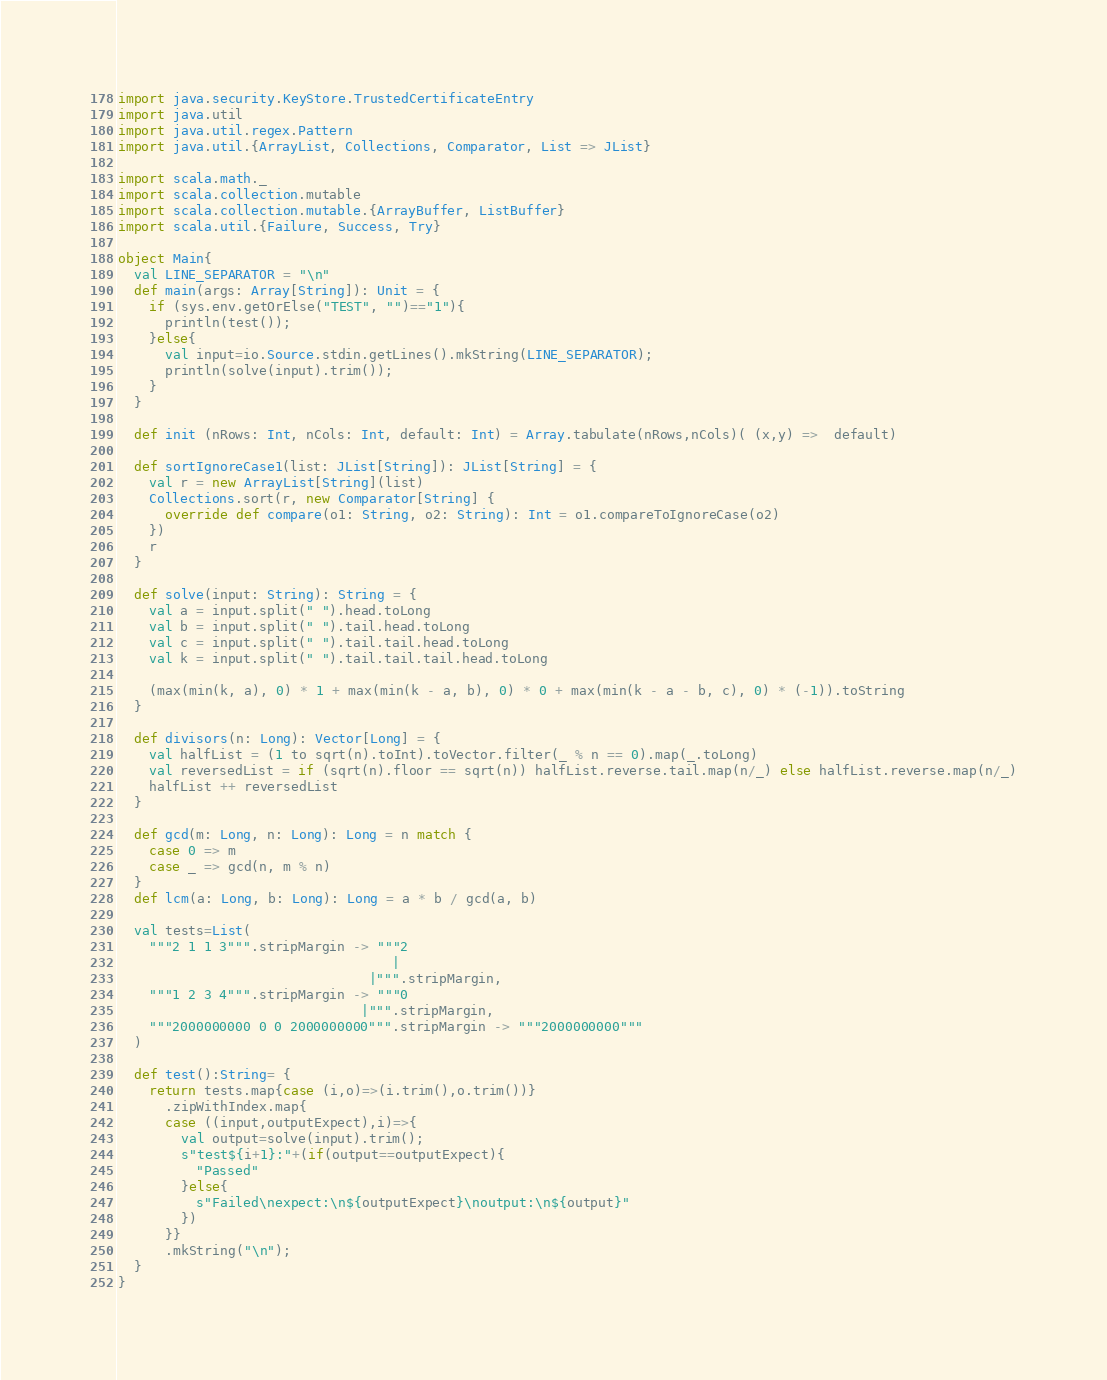<code> <loc_0><loc_0><loc_500><loc_500><_Scala_>import java.security.KeyStore.TrustedCertificateEntry
import java.util
import java.util.regex.Pattern
import java.util.{ArrayList, Collections, Comparator, List => JList}

import scala.math._
import scala.collection.mutable
import scala.collection.mutable.{ArrayBuffer, ListBuffer}
import scala.util.{Failure, Success, Try}

object Main{
  val LINE_SEPARATOR = "\n"
  def main(args: Array[String]): Unit = {
    if (sys.env.getOrElse("TEST", "")=="1"){
      println(test());
    }else{
      val input=io.Source.stdin.getLines().mkString(LINE_SEPARATOR);
      println(solve(input).trim());
    }
  }

  def init (nRows: Int, nCols: Int, default: Int) = Array.tabulate(nRows,nCols)( (x,y) =>  default)

  def sortIgnoreCase1(list: JList[String]): JList[String] = {
    val r = new ArrayList[String](list)
    Collections.sort(r, new Comparator[String] {
      override def compare(o1: String, o2: String): Int = o1.compareToIgnoreCase(o2)
    })
    r
  }

  def solve(input: String): String = {
    val a = input.split(" ").head.toLong
    val b = input.split(" ").tail.head.toLong
    val c = input.split(" ").tail.tail.head.toLong
    val k = input.split(" ").tail.tail.tail.head.toLong

    (max(min(k, a), 0) * 1 + max(min(k - a, b), 0) * 0 + max(min(k - a - b, c), 0) * (-1)).toString
  }

  def divisors(n: Long): Vector[Long] = {
    val halfList = (1 to sqrt(n).toInt).toVector.filter(_ % n == 0).map(_.toLong)
    val reversedList = if (sqrt(n).floor == sqrt(n)) halfList.reverse.tail.map(n/_) else halfList.reverse.map(n/_)
    halfList ++ reversedList
  }

  def gcd(m: Long, n: Long): Long = n match {
    case 0 => m
    case _ => gcd(n, m % n)
  }
  def lcm(a: Long, b: Long): Long = a * b / gcd(a, b)

  val tests=List(
    """2 1 1 3""".stripMargin -> """2
                                   |
                                |""".stripMargin,
    """1 2 3 4""".stripMargin -> """0
                               |""".stripMargin,
    """2000000000 0 0 2000000000""".stripMargin -> """2000000000"""
  )

  def test():String= {
    return tests.map{case (i,o)=>(i.trim(),o.trim())}
      .zipWithIndex.map{
      case ((input,outputExpect),i)=>{
        val output=solve(input).trim();
        s"test${i+1}:"+(if(output==outputExpect){
          "Passed"
        }else{
          s"Failed\nexpect:\n${outputExpect}\noutput:\n${output}"
        })
      }}
      .mkString("\n");
  }
}</code> 